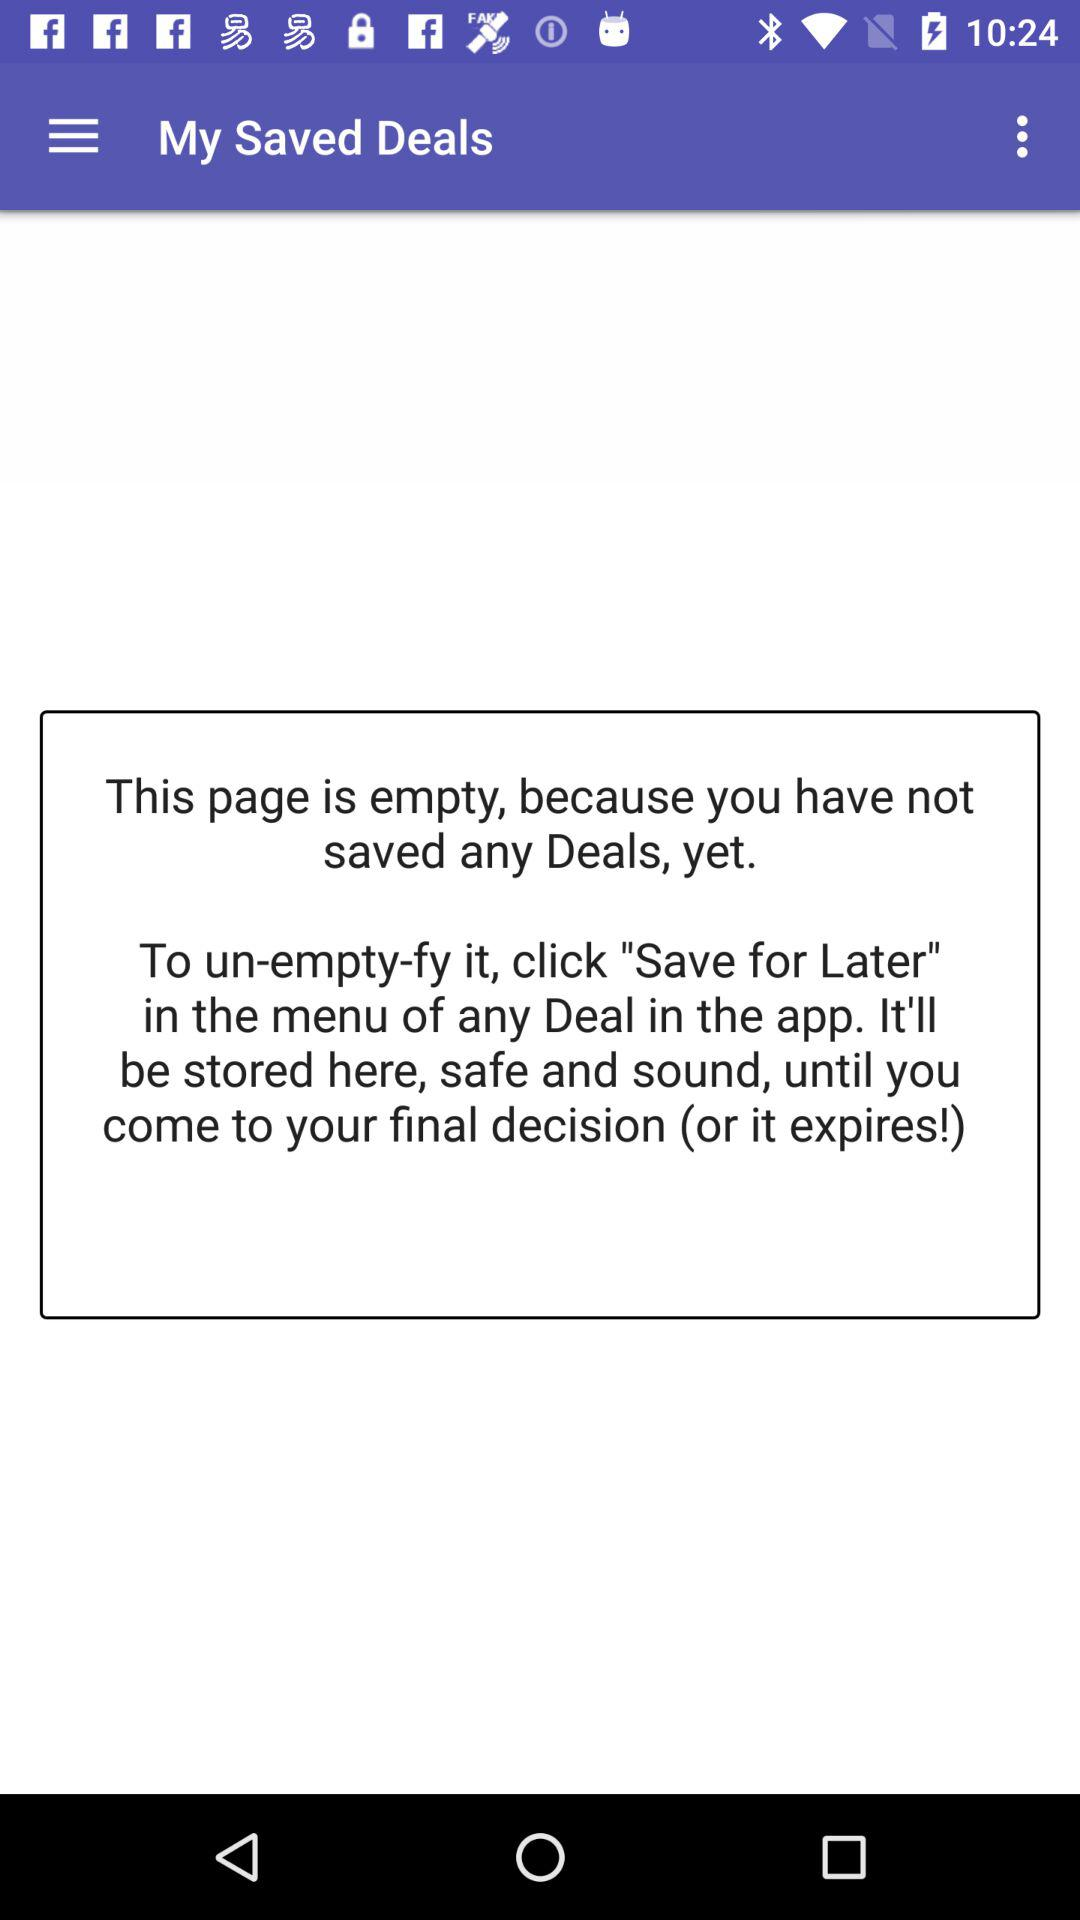Are there any deals saved? There are no deals saved. 